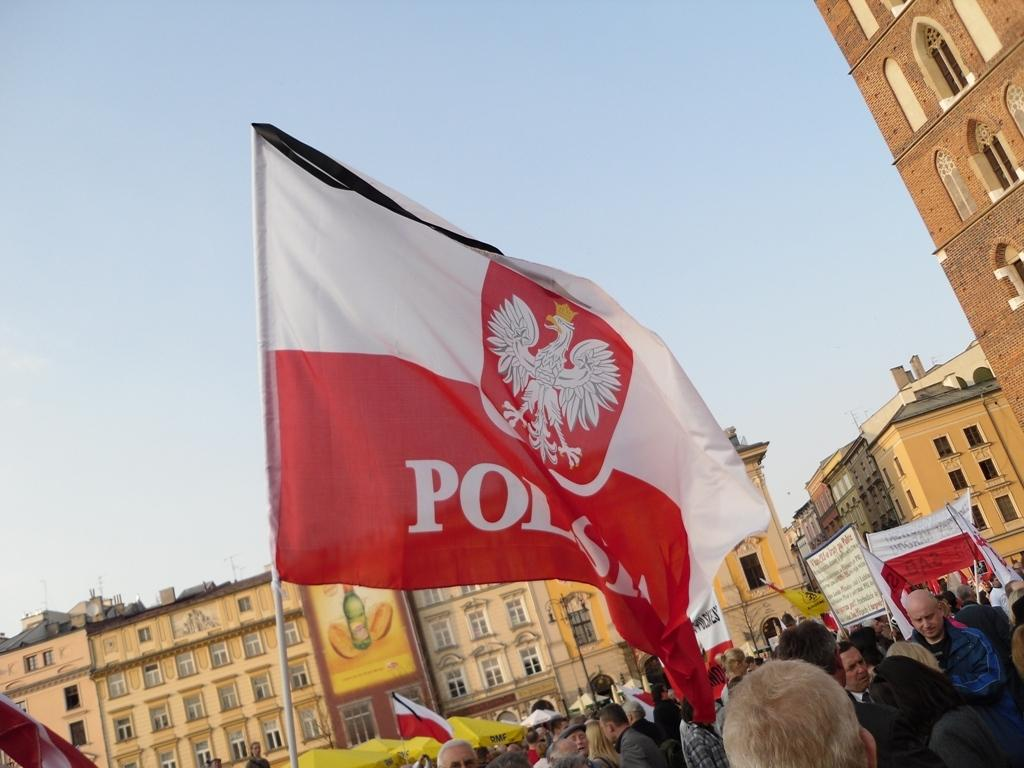What is the main subject in the center of the image? There is a flag in the center of the image. What can be seen at the bottom of the image? There are persons on the road at the bottom of the image. What is visible in the background of the image? There are buildings and the sky in the background of the image. What type of gate can be seen in the image? There is no gate present in the image. Is there a crib visible in the image? There is no crib present in the image. 